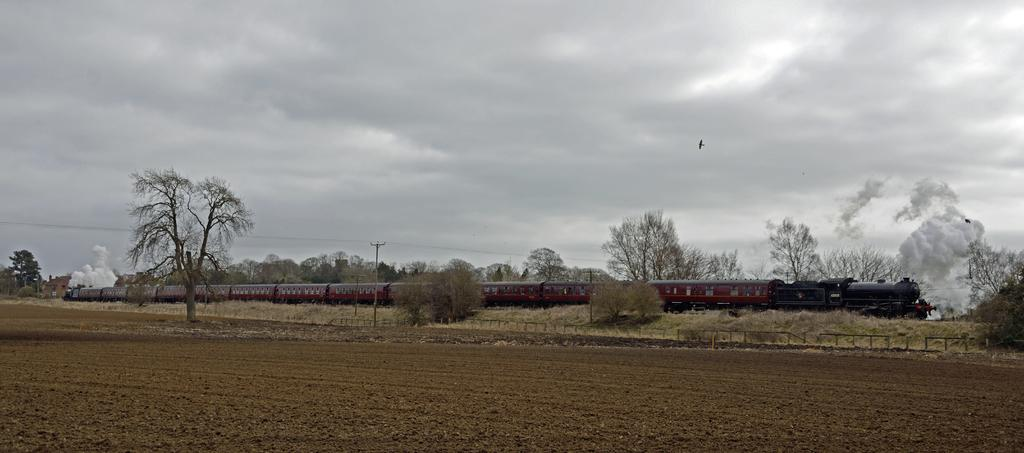What type of surface is visible in the image? There is ground in the image. What can be seen in the distance in the image? There are trees, plants, and a train visible in the background? What type of vegetation is present on the ground in the image? There is grass on the ground in the image. What else can be seen in the background of the image? There is a pole in the background of the image. What is flying in the air in the image? There is a bird in the air in the image. What is visible in the sky in the image? There are clouds in the sky in the image. What is the profit made by the bird in the image? There is no mention of profit in the image, and the bird is not engaged in any activity that would generate profit. 